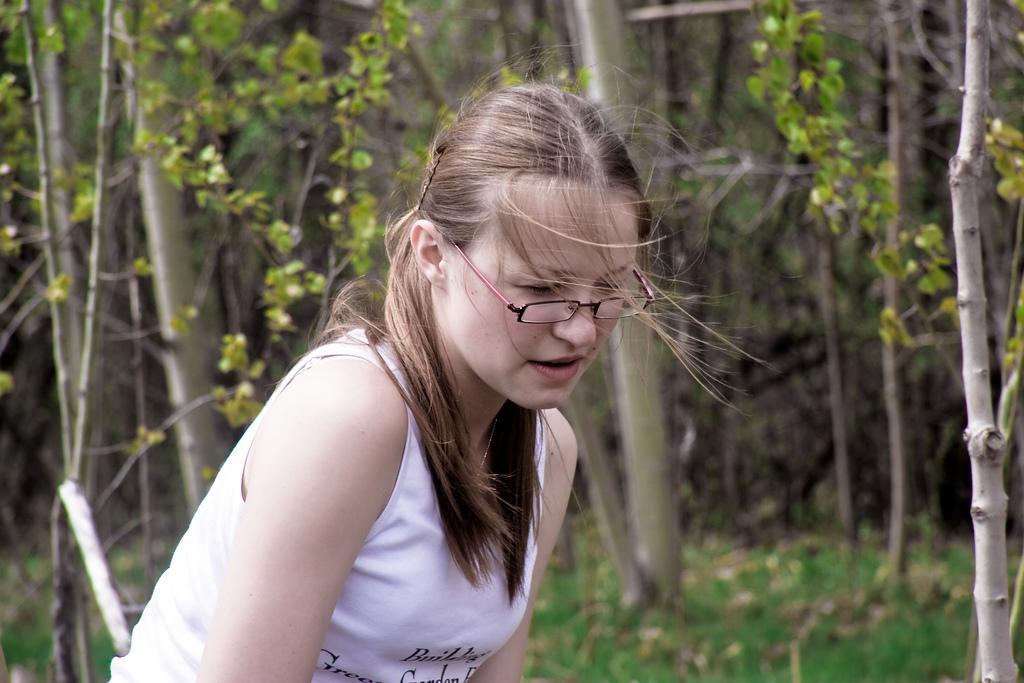Please provide a concise description of this image. In this image, I can see a woman with spectacles. In the background, there are trees. 